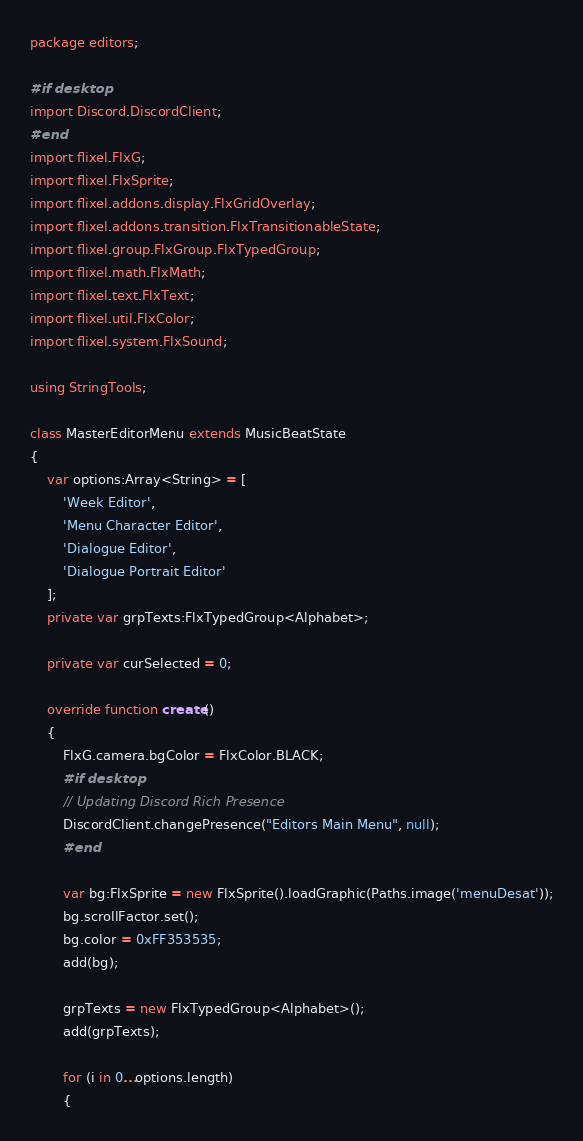<code> <loc_0><loc_0><loc_500><loc_500><_Haxe_>package editors;

#if desktop
import Discord.DiscordClient;
#end
import flixel.FlxG;
import flixel.FlxSprite;
import flixel.addons.display.FlxGridOverlay;
import flixel.addons.transition.FlxTransitionableState;
import flixel.group.FlxGroup.FlxTypedGroup;
import flixel.math.FlxMath;
import flixel.text.FlxText;
import flixel.util.FlxColor;
import flixel.system.FlxSound;

using StringTools;

class MasterEditorMenu extends MusicBeatState
{
	var options:Array<String> = [
		'Week Editor',
		'Menu Character Editor',
		'Dialogue Editor',
		'Dialogue Portrait Editor'
	];
	private var grpTexts:FlxTypedGroup<Alphabet>;

	private var curSelected = 0;

	override function create()
	{
		FlxG.camera.bgColor = FlxColor.BLACK;
		#if desktop
		// Updating Discord Rich Presence
		DiscordClient.changePresence("Editors Main Menu", null);
		#end

		var bg:FlxSprite = new FlxSprite().loadGraphic(Paths.image('menuDesat'));
		bg.scrollFactor.set();
		bg.color = 0xFF353535;
		add(bg);

		grpTexts = new FlxTypedGroup<Alphabet>();
		add(grpTexts);

		for (i in 0...options.length)
		{</code> 